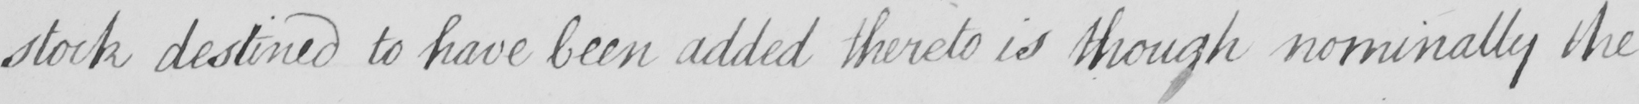What text is written in this handwritten line? stock destined to have been added thereto is though nominally the 